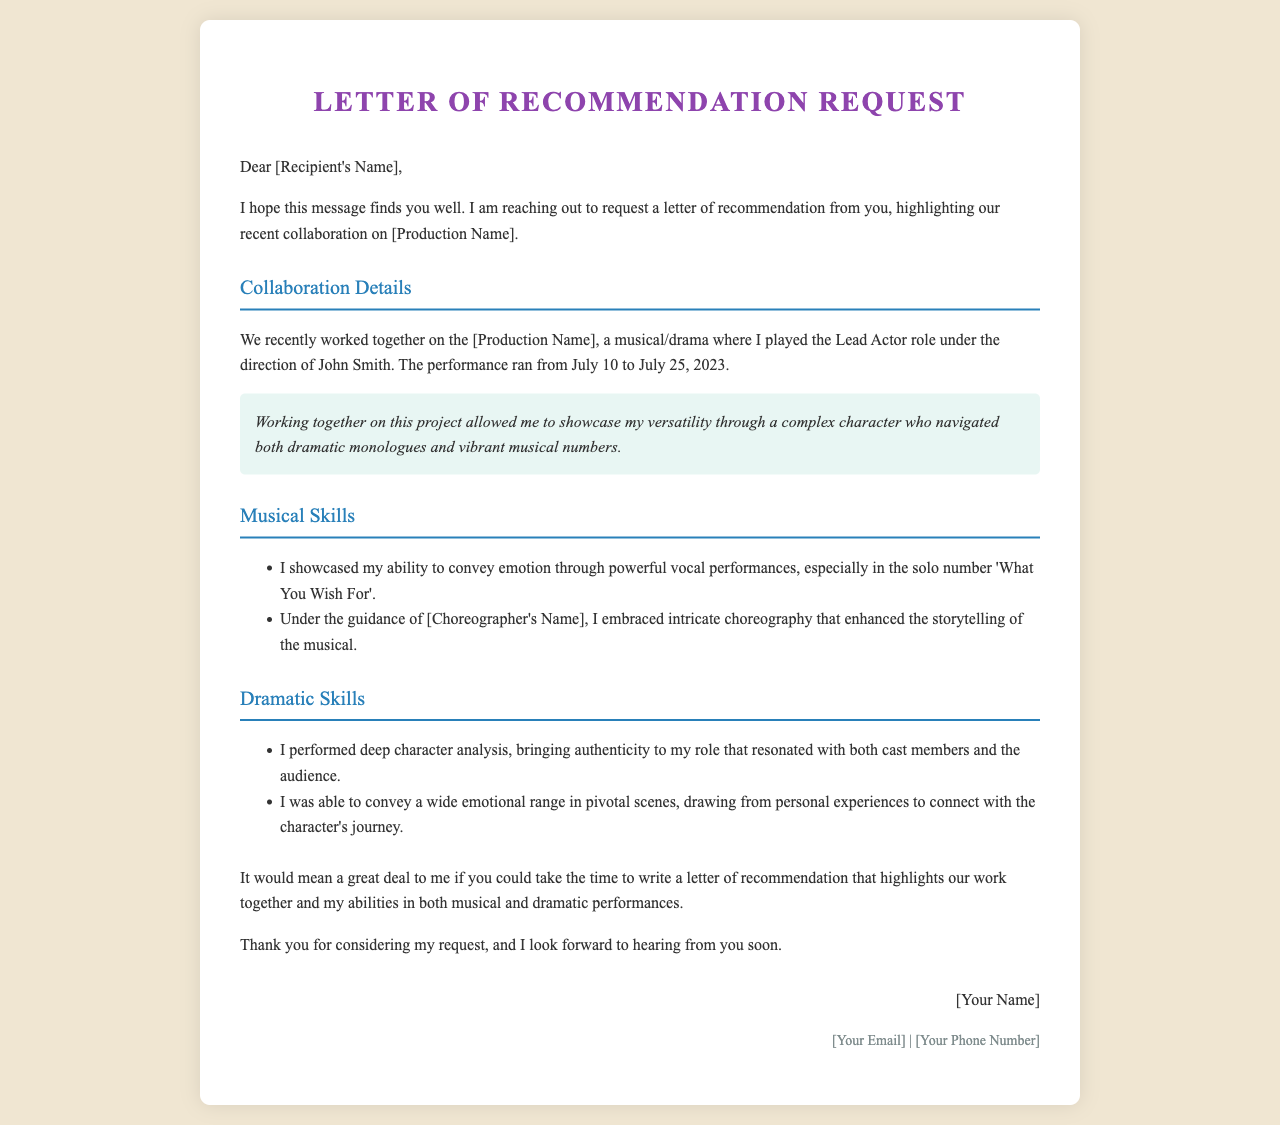What is the title of the document? The title of the document is presented in the <h1> tag as "Letter of Recommendation Request".
Answer: Letter of Recommendation Request Who directed the production mentioned in the document? The director's name is mentioned as "John Smith" in the collaboration details.
Answer: John Smith What role did the performer play in the production? The role is specified as "Lead Actor" within the document.
Answer: Lead Actor What were the performance dates for the production? The performance ran from July 10 to July 25, 2023, as noted in the collaboration details.
Answer: July 10 to July 25, 2023 What is highlighted as a key aspect of the performer's versatility? The letter mentions showcasing versatility through a character with dramatic monologues and musical numbers.
Answer: Complex character who navigated both dramatic monologues and vibrant musical numbers What emotional skill did the performer showcase in the musical number? The document cites "powerful vocal performances" to convey emotion during the solo number.
Answer: Powerful vocal performances How did the performer contribute to the dramatic elements of their role? The performer performed deep character analysis to bring authenticity.
Answer: Deep character analysis What is the request made to the recipient of the letter? The request made is for a letter of recommendation from the recipient.
Answer: Letter of recommendation 